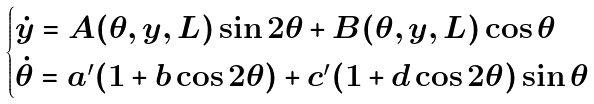<formula> <loc_0><loc_0><loc_500><loc_500>\begin{cases} \dot { y } = A ( \theta , y , L ) \sin 2 \theta + B ( \theta , y , L ) \cos \theta \\ \dot { \theta } = a ^ { \prime } ( 1 + b \cos 2 \theta ) + c ^ { \prime } ( 1 + d \cos 2 \theta ) \sin \theta \\ \end{cases}</formula> 